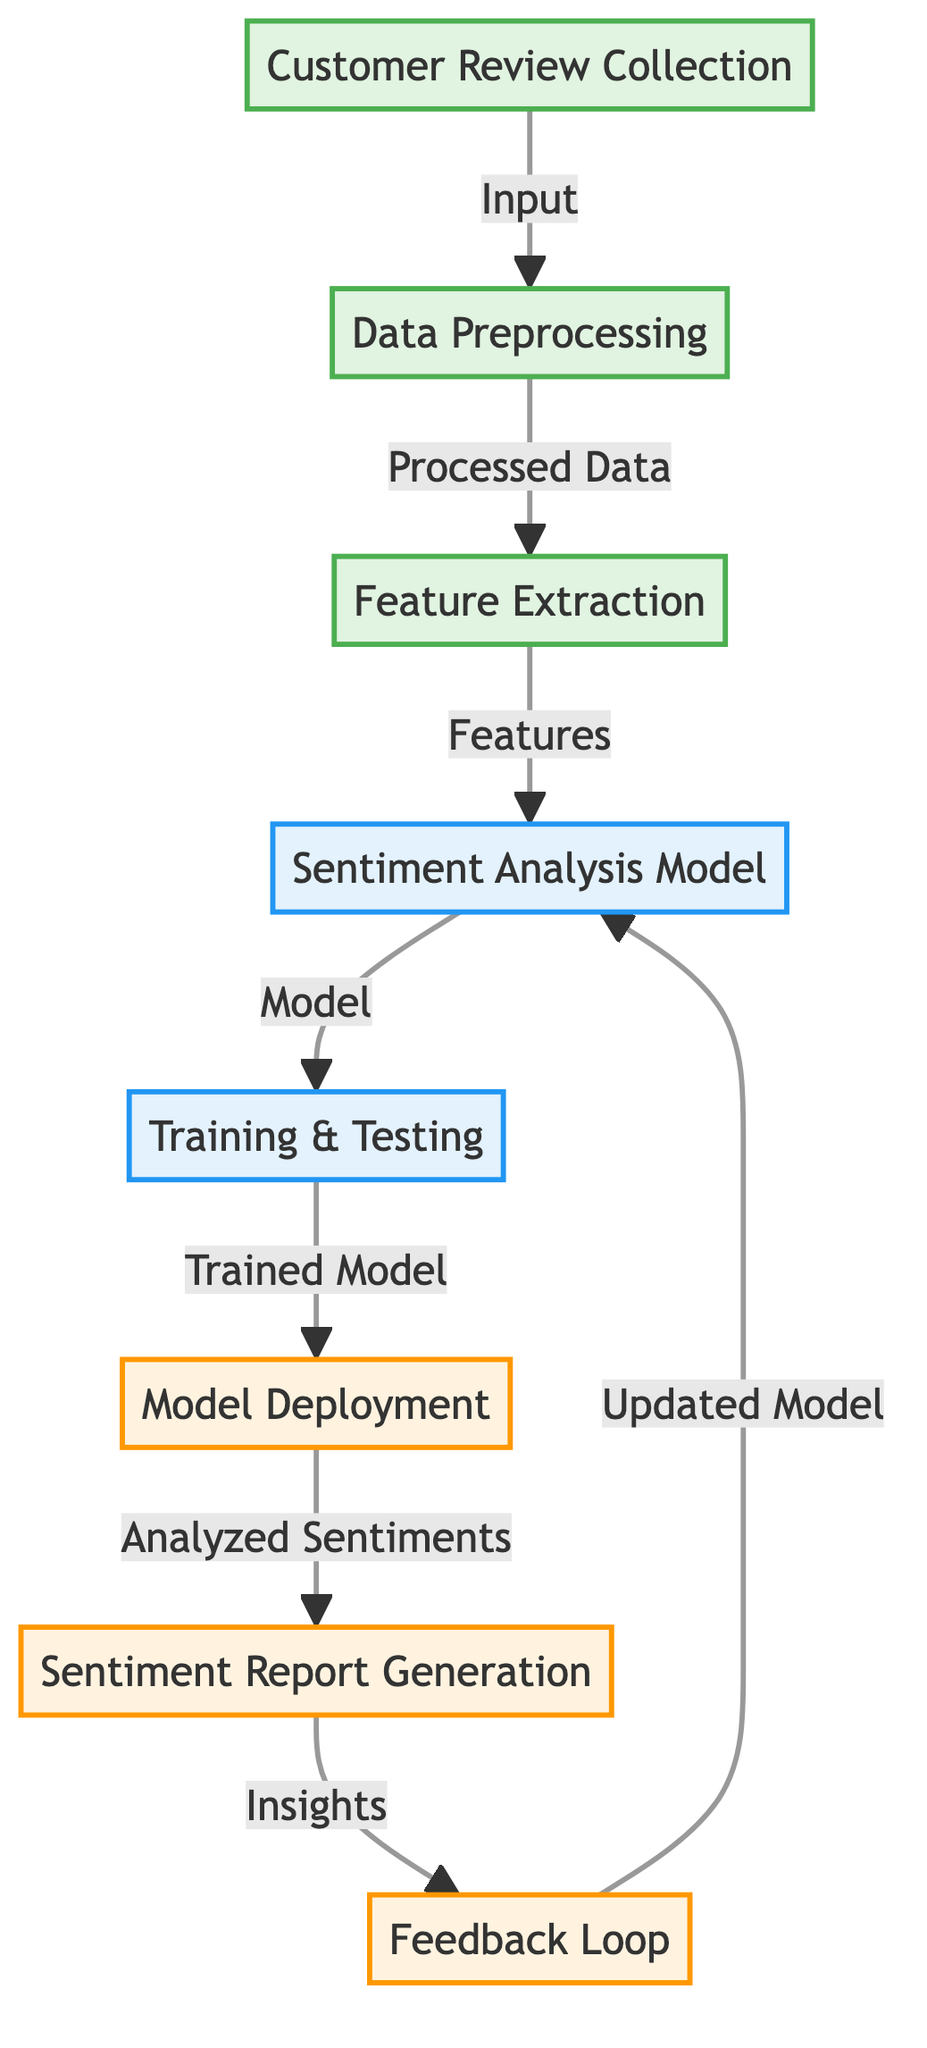What is the starting point of the diagram? The diagram begins with the node “Customer Review Collection”, indicating the first step in the sentiment analysis process.
Answer: Customer Review Collection How many main processes are in the diagram? The diagram features six main processes, which are distinct actions leading up to model outcome and deployment.
Answer: Six Which node represents the output of the model? The node named “Sentiment Report Generation” signifies the output of the sentiment analysis model, illustrating the results of the analysis.
Answer: Sentiment Report Generation What connects the “Training & Testing” node to the “Model Deployment” node? The edge between these two nodes is labeled as “Trained Model”, indicating the output from training and testing leading to model deployment.
Answer: Trained Model How does the system incorporate feedback? The node “Feedback Loop” receives insights from the “Sentiment Report Generation” and sends updates back to the “Sentiment Analysis Model”.
Answer: By updated model What role does the “Feature Extraction” node play in the process? The node “Feature Extraction” processes the data after preprocessing to identify significant features that will be used by the sentiment analysis model.
Answer: Identifies features What happens after the “Model Deployment”? Following the model deployment, the next step is to generate the sentiment report, capturing the analysis results.
Answer: Sentiment Report Generation What is the relationship between “Analyzed Sentiments” and “Feedback Loop”? The relationship is that the insights gained from analyzed sentiments inform the feedback loop, which in turn updates the sentiment analysis model.
Answer: Insights update model Where does the data go after preprocessing? After preprocessing, the data flows to “Feature Extraction” where critical features are derived for use in the model.
Answer: Feature Extraction 